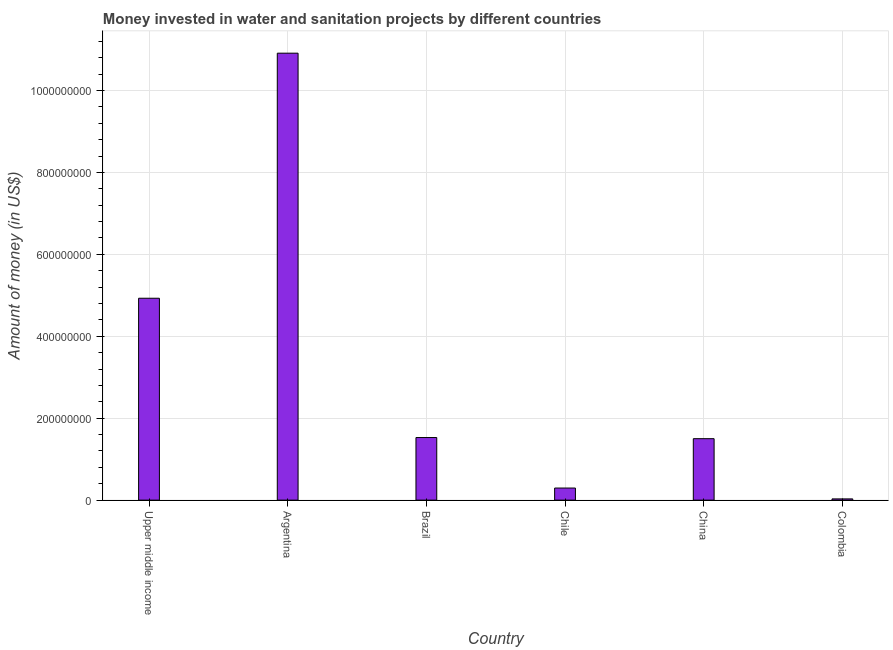What is the title of the graph?
Provide a short and direct response. Money invested in water and sanitation projects by different countries. What is the label or title of the X-axis?
Keep it short and to the point. Country. What is the label or title of the Y-axis?
Give a very brief answer. Amount of money (in US$). What is the investment in Upper middle income?
Keep it short and to the point. 4.93e+08. Across all countries, what is the maximum investment?
Your response must be concise. 1.09e+09. In which country was the investment maximum?
Provide a succinct answer. Argentina. What is the sum of the investment?
Provide a succinct answer. 1.92e+09. What is the difference between the investment in Chile and Upper middle income?
Your answer should be very brief. -4.63e+08. What is the average investment per country?
Offer a very short reply. 3.20e+08. What is the median investment?
Provide a short and direct response. 1.51e+08. In how many countries, is the investment greater than 360000000 US$?
Offer a very short reply. 2. What is the ratio of the investment in Brazil to that in Upper middle income?
Provide a short and direct response. 0.31. Is the difference between the investment in Brazil and Chile greater than the difference between any two countries?
Provide a succinct answer. No. What is the difference between the highest and the second highest investment?
Provide a succinct answer. 5.98e+08. Is the sum of the investment in Argentina and China greater than the maximum investment across all countries?
Make the answer very short. Yes. What is the difference between the highest and the lowest investment?
Offer a terse response. 1.09e+09. In how many countries, is the investment greater than the average investment taken over all countries?
Provide a succinct answer. 2. Are all the bars in the graph horizontal?
Give a very brief answer. No. Are the values on the major ticks of Y-axis written in scientific E-notation?
Keep it short and to the point. No. What is the Amount of money (in US$) of Upper middle income?
Offer a very short reply. 4.93e+08. What is the Amount of money (in US$) in Argentina?
Offer a terse response. 1.09e+09. What is the Amount of money (in US$) of Brazil?
Ensure brevity in your answer.  1.53e+08. What is the Amount of money (in US$) in Chile?
Provide a short and direct response. 2.95e+07. What is the Amount of money (in US$) of China?
Ensure brevity in your answer.  1.50e+08. What is the difference between the Amount of money (in US$) in Upper middle income and Argentina?
Ensure brevity in your answer.  -5.98e+08. What is the difference between the Amount of money (in US$) in Upper middle income and Brazil?
Offer a very short reply. 3.40e+08. What is the difference between the Amount of money (in US$) in Upper middle income and Chile?
Give a very brief answer. 4.63e+08. What is the difference between the Amount of money (in US$) in Upper middle income and China?
Keep it short and to the point. 3.43e+08. What is the difference between the Amount of money (in US$) in Upper middle income and Colombia?
Keep it short and to the point. 4.90e+08. What is the difference between the Amount of money (in US$) in Argentina and Brazil?
Make the answer very short. 9.38e+08. What is the difference between the Amount of money (in US$) in Argentina and Chile?
Offer a very short reply. 1.06e+09. What is the difference between the Amount of money (in US$) in Argentina and China?
Provide a succinct answer. 9.41e+08. What is the difference between the Amount of money (in US$) in Argentina and Colombia?
Your response must be concise. 1.09e+09. What is the difference between the Amount of money (in US$) in Brazil and Chile?
Offer a terse response. 1.23e+08. What is the difference between the Amount of money (in US$) in Brazil and China?
Your answer should be compact. 2.80e+06. What is the difference between the Amount of money (in US$) in Brazil and Colombia?
Ensure brevity in your answer.  1.50e+08. What is the difference between the Amount of money (in US$) in Chile and China?
Provide a short and direct response. -1.20e+08. What is the difference between the Amount of money (in US$) in Chile and Colombia?
Provide a short and direct response. 2.65e+07. What is the difference between the Amount of money (in US$) in China and Colombia?
Give a very brief answer. 1.47e+08. What is the ratio of the Amount of money (in US$) in Upper middle income to that in Argentina?
Ensure brevity in your answer.  0.45. What is the ratio of the Amount of money (in US$) in Upper middle income to that in Brazil?
Your answer should be very brief. 3.23. What is the ratio of the Amount of money (in US$) in Upper middle income to that in Chile?
Offer a very short reply. 16.7. What is the ratio of the Amount of money (in US$) in Upper middle income to that in China?
Offer a very short reply. 3.29. What is the ratio of the Amount of money (in US$) in Upper middle income to that in Colombia?
Provide a succinct answer. 164.27. What is the ratio of the Amount of money (in US$) in Argentina to that in Brazil?
Offer a terse response. 7.14. What is the ratio of the Amount of money (in US$) in Argentina to that in Chile?
Your answer should be very brief. 36.98. What is the ratio of the Amount of money (in US$) in Argentina to that in China?
Keep it short and to the point. 7.27. What is the ratio of the Amount of money (in US$) in Argentina to that in Colombia?
Your answer should be compact. 363.67. What is the ratio of the Amount of money (in US$) in Brazil to that in Chile?
Your answer should be very brief. 5.18. What is the ratio of the Amount of money (in US$) in Brazil to that in China?
Your answer should be compact. 1.02. What is the ratio of the Amount of money (in US$) in Brazil to that in Colombia?
Provide a succinct answer. 50.93. What is the ratio of the Amount of money (in US$) in Chile to that in China?
Give a very brief answer. 0.2. What is the ratio of the Amount of money (in US$) in Chile to that in Colombia?
Your response must be concise. 9.83. 